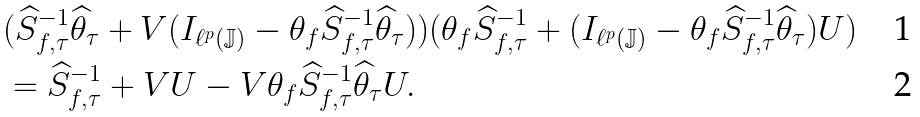<formula> <loc_0><loc_0><loc_500><loc_500>& ( \widehat { S } _ { f , \tau } ^ { - 1 } \widehat { \theta } _ { \tau } + V ( I _ { \ell ^ { p } ( \mathbb { J } ) } - \theta _ { f } \widehat { S } _ { f , \tau } ^ { - 1 } \widehat { \theta } _ { \tau } ) ) ( \theta _ { f } \widehat { S } _ { f , \tau } ^ { - 1 } + ( I _ { \ell ^ { p } ( \mathbb { J } ) } - \theta _ { f } \widehat { S } _ { f , \tau } ^ { - 1 } \widehat { \theta } _ { \tau } ) U ) \\ & = \widehat { S } _ { f , \tau } ^ { - 1 } + V U - V \theta _ { f } \widehat { S } _ { f , \tau } ^ { - 1 } \widehat { \theta } _ { \tau } U .</formula> 